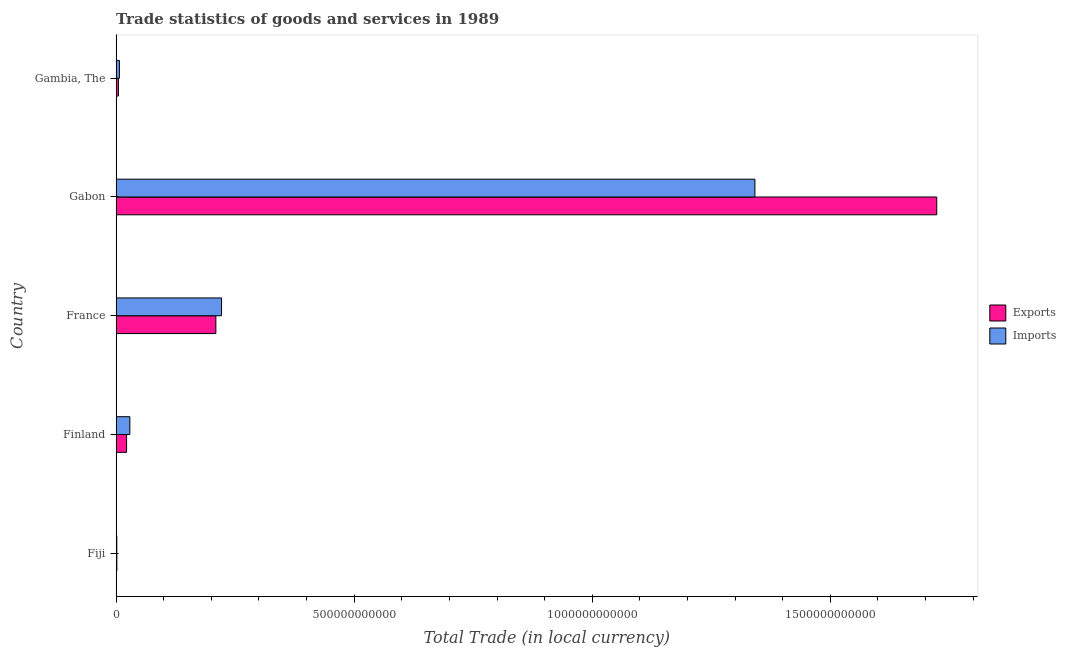How many groups of bars are there?
Ensure brevity in your answer.  5. Are the number of bars per tick equal to the number of legend labels?
Ensure brevity in your answer.  Yes. Are the number of bars on each tick of the Y-axis equal?
Provide a succinct answer. Yes. How many bars are there on the 5th tick from the bottom?
Your response must be concise. 2. What is the label of the 4th group of bars from the top?
Offer a very short reply. Finland. In how many cases, is the number of bars for a given country not equal to the number of legend labels?
Offer a very short reply. 0. What is the imports of goods and services in Gambia, The?
Offer a very short reply. 6.91e+09. Across all countries, what is the maximum export of goods and services?
Provide a succinct answer. 1.72e+12. Across all countries, what is the minimum imports of goods and services?
Your answer should be compact. 1.39e+09. In which country was the export of goods and services maximum?
Provide a short and direct response. Gabon. In which country was the imports of goods and services minimum?
Your answer should be very brief. Fiji. What is the total imports of goods and services in the graph?
Make the answer very short. 1.60e+12. What is the difference between the imports of goods and services in France and that in Gambia, The?
Keep it short and to the point. 2.14e+11. What is the difference between the imports of goods and services in Gambia, The and the export of goods and services in France?
Provide a short and direct response. -2.03e+11. What is the average export of goods and services per country?
Ensure brevity in your answer.  3.92e+11. What is the difference between the imports of goods and services and export of goods and services in Finland?
Provide a short and direct response. 6.83e+09. In how many countries, is the export of goods and services greater than 1100000000000 LCU?
Provide a succinct answer. 1. What is the ratio of the imports of goods and services in France to that in Gabon?
Ensure brevity in your answer.  0.17. Is the imports of goods and services in Finland less than that in France?
Your answer should be compact. Yes. What is the difference between the highest and the second highest imports of goods and services?
Provide a succinct answer. 1.12e+12. What is the difference between the highest and the lowest export of goods and services?
Your response must be concise. 1.72e+12. In how many countries, is the export of goods and services greater than the average export of goods and services taken over all countries?
Offer a very short reply. 1. What does the 2nd bar from the top in Gambia, The represents?
Offer a terse response. Exports. What does the 1st bar from the bottom in Fiji represents?
Ensure brevity in your answer.  Exports. Are all the bars in the graph horizontal?
Give a very brief answer. Yes. How many countries are there in the graph?
Your answer should be compact. 5. What is the difference between two consecutive major ticks on the X-axis?
Offer a terse response. 5.00e+11. Where does the legend appear in the graph?
Give a very brief answer. Center right. What is the title of the graph?
Offer a terse response. Trade statistics of goods and services in 1989. What is the label or title of the X-axis?
Your response must be concise. Total Trade (in local currency). What is the label or title of the Y-axis?
Provide a short and direct response. Country. What is the Total Trade (in local currency) of Exports in Fiji?
Offer a very short reply. 1.53e+09. What is the Total Trade (in local currency) in Imports in Fiji?
Your answer should be very brief. 1.39e+09. What is the Total Trade (in local currency) in Exports in Finland?
Your response must be concise. 2.20e+1. What is the Total Trade (in local currency) in Imports in Finland?
Ensure brevity in your answer.  2.88e+1. What is the Total Trade (in local currency) of Exports in France?
Your response must be concise. 2.09e+11. What is the Total Trade (in local currency) of Imports in France?
Make the answer very short. 2.21e+11. What is the Total Trade (in local currency) in Exports in Gabon?
Offer a very short reply. 1.72e+12. What is the Total Trade (in local currency) of Imports in Gabon?
Keep it short and to the point. 1.34e+12. What is the Total Trade (in local currency) of Exports in Gambia, The?
Your answer should be compact. 4.78e+09. What is the Total Trade (in local currency) in Imports in Gambia, The?
Your response must be concise. 6.91e+09. Across all countries, what is the maximum Total Trade (in local currency) in Exports?
Your answer should be very brief. 1.72e+12. Across all countries, what is the maximum Total Trade (in local currency) in Imports?
Provide a short and direct response. 1.34e+12. Across all countries, what is the minimum Total Trade (in local currency) in Exports?
Ensure brevity in your answer.  1.53e+09. Across all countries, what is the minimum Total Trade (in local currency) in Imports?
Your response must be concise. 1.39e+09. What is the total Total Trade (in local currency) in Exports in the graph?
Ensure brevity in your answer.  1.96e+12. What is the total Total Trade (in local currency) of Imports in the graph?
Make the answer very short. 1.60e+12. What is the difference between the Total Trade (in local currency) in Exports in Fiji and that in Finland?
Give a very brief answer. -2.04e+1. What is the difference between the Total Trade (in local currency) of Imports in Fiji and that in Finland?
Provide a short and direct response. -2.74e+1. What is the difference between the Total Trade (in local currency) of Exports in Fiji and that in France?
Keep it short and to the point. -2.08e+11. What is the difference between the Total Trade (in local currency) in Imports in Fiji and that in France?
Keep it short and to the point. -2.20e+11. What is the difference between the Total Trade (in local currency) of Exports in Fiji and that in Gabon?
Your answer should be compact. -1.72e+12. What is the difference between the Total Trade (in local currency) of Imports in Fiji and that in Gabon?
Offer a terse response. -1.34e+12. What is the difference between the Total Trade (in local currency) in Exports in Fiji and that in Gambia, The?
Your answer should be compact. -3.25e+09. What is the difference between the Total Trade (in local currency) of Imports in Fiji and that in Gambia, The?
Give a very brief answer. -5.52e+09. What is the difference between the Total Trade (in local currency) of Exports in Finland and that in France?
Your answer should be compact. -1.87e+11. What is the difference between the Total Trade (in local currency) of Imports in Finland and that in France?
Your answer should be compact. -1.93e+11. What is the difference between the Total Trade (in local currency) in Exports in Finland and that in Gabon?
Offer a very short reply. -1.70e+12. What is the difference between the Total Trade (in local currency) in Imports in Finland and that in Gabon?
Keep it short and to the point. -1.31e+12. What is the difference between the Total Trade (in local currency) of Exports in Finland and that in Gambia, The?
Offer a very short reply. 1.72e+1. What is the difference between the Total Trade (in local currency) of Imports in Finland and that in Gambia, The?
Your response must be concise. 2.19e+1. What is the difference between the Total Trade (in local currency) of Exports in France and that in Gabon?
Make the answer very short. -1.51e+12. What is the difference between the Total Trade (in local currency) in Imports in France and that in Gabon?
Keep it short and to the point. -1.12e+12. What is the difference between the Total Trade (in local currency) in Exports in France and that in Gambia, The?
Keep it short and to the point. 2.05e+11. What is the difference between the Total Trade (in local currency) of Imports in France and that in Gambia, The?
Provide a succinct answer. 2.14e+11. What is the difference between the Total Trade (in local currency) of Exports in Gabon and that in Gambia, The?
Provide a succinct answer. 1.72e+12. What is the difference between the Total Trade (in local currency) in Imports in Gabon and that in Gambia, The?
Your answer should be very brief. 1.33e+12. What is the difference between the Total Trade (in local currency) in Exports in Fiji and the Total Trade (in local currency) in Imports in Finland?
Offer a very short reply. -2.73e+1. What is the difference between the Total Trade (in local currency) of Exports in Fiji and the Total Trade (in local currency) of Imports in France?
Keep it short and to the point. -2.20e+11. What is the difference between the Total Trade (in local currency) in Exports in Fiji and the Total Trade (in local currency) in Imports in Gabon?
Offer a very short reply. -1.34e+12. What is the difference between the Total Trade (in local currency) of Exports in Fiji and the Total Trade (in local currency) of Imports in Gambia, The?
Offer a terse response. -5.38e+09. What is the difference between the Total Trade (in local currency) in Exports in Finland and the Total Trade (in local currency) in Imports in France?
Your response must be concise. -1.99e+11. What is the difference between the Total Trade (in local currency) in Exports in Finland and the Total Trade (in local currency) in Imports in Gabon?
Offer a terse response. -1.32e+12. What is the difference between the Total Trade (in local currency) of Exports in Finland and the Total Trade (in local currency) of Imports in Gambia, The?
Provide a succinct answer. 1.51e+1. What is the difference between the Total Trade (in local currency) in Exports in France and the Total Trade (in local currency) in Imports in Gabon?
Your answer should be very brief. -1.13e+12. What is the difference between the Total Trade (in local currency) of Exports in France and the Total Trade (in local currency) of Imports in Gambia, The?
Your answer should be compact. 2.03e+11. What is the difference between the Total Trade (in local currency) in Exports in Gabon and the Total Trade (in local currency) in Imports in Gambia, The?
Your response must be concise. 1.72e+12. What is the average Total Trade (in local currency) of Exports per country?
Make the answer very short. 3.92e+11. What is the average Total Trade (in local currency) in Imports per country?
Keep it short and to the point. 3.20e+11. What is the difference between the Total Trade (in local currency) in Exports and Total Trade (in local currency) in Imports in Fiji?
Your response must be concise. 1.39e+08. What is the difference between the Total Trade (in local currency) in Exports and Total Trade (in local currency) in Imports in Finland?
Your answer should be very brief. -6.83e+09. What is the difference between the Total Trade (in local currency) in Exports and Total Trade (in local currency) in Imports in France?
Keep it short and to the point. -1.19e+1. What is the difference between the Total Trade (in local currency) in Exports and Total Trade (in local currency) in Imports in Gabon?
Offer a very short reply. 3.82e+11. What is the difference between the Total Trade (in local currency) of Exports and Total Trade (in local currency) of Imports in Gambia, The?
Make the answer very short. -2.13e+09. What is the ratio of the Total Trade (in local currency) in Exports in Fiji to that in Finland?
Give a very brief answer. 0.07. What is the ratio of the Total Trade (in local currency) in Imports in Fiji to that in Finland?
Your response must be concise. 0.05. What is the ratio of the Total Trade (in local currency) of Exports in Fiji to that in France?
Offer a very short reply. 0.01. What is the ratio of the Total Trade (in local currency) of Imports in Fiji to that in France?
Make the answer very short. 0.01. What is the ratio of the Total Trade (in local currency) of Exports in Fiji to that in Gabon?
Your answer should be compact. 0. What is the ratio of the Total Trade (in local currency) of Exports in Fiji to that in Gambia, The?
Provide a short and direct response. 0.32. What is the ratio of the Total Trade (in local currency) in Imports in Fiji to that in Gambia, The?
Provide a short and direct response. 0.2. What is the ratio of the Total Trade (in local currency) in Exports in Finland to that in France?
Provide a short and direct response. 0.1. What is the ratio of the Total Trade (in local currency) of Imports in Finland to that in France?
Offer a very short reply. 0.13. What is the ratio of the Total Trade (in local currency) in Exports in Finland to that in Gabon?
Your response must be concise. 0.01. What is the ratio of the Total Trade (in local currency) of Imports in Finland to that in Gabon?
Your answer should be compact. 0.02. What is the ratio of the Total Trade (in local currency) in Exports in Finland to that in Gambia, The?
Your answer should be very brief. 4.6. What is the ratio of the Total Trade (in local currency) in Imports in Finland to that in Gambia, The?
Make the answer very short. 4.17. What is the ratio of the Total Trade (in local currency) in Exports in France to that in Gabon?
Your response must be concise. 0.12. What is the ratio of the Total Trade (in local currency) in Imports in France to that in Gabon?
Keep it short and to the point. 0.17. What is the ratio of the Total Trade (in local currency) in Exports in France to that in Gambia, The?
Ensure brevity in your answer.  43.83. What is the ratio of the Total Trade (in local currency) of Imports in France to that in Gambia, The?
Offer a terse response. 32.04. What is the ratio of the Total Trade (in local currency) of Exports in Gabon to that in Gambia, The?
Provide a succinct answer. 360.67. What is the ratio of the Total Trade (in local currency) of Imports in Gabon to that in Gambia, The?
Give a very brief answer. 194.14. What is the difference between the highest and the second highest Total Trade (in local currency) of Exports?
Give a very brief answer. 1.51e+12. What is the difference between the highest and the second highest Total Trade (in local currency) of Imports?
Offer a terse response. 1.12e+12. What is the difference between the highest and the lowest Total Trade (in local currency) in Exports?
Offer a very short reply. 1.72e+12. What is the difference between the highest and the lowest Total Trade (in local currency) of Imports?
Ensure brevity in your answer.  1.34e+12. 